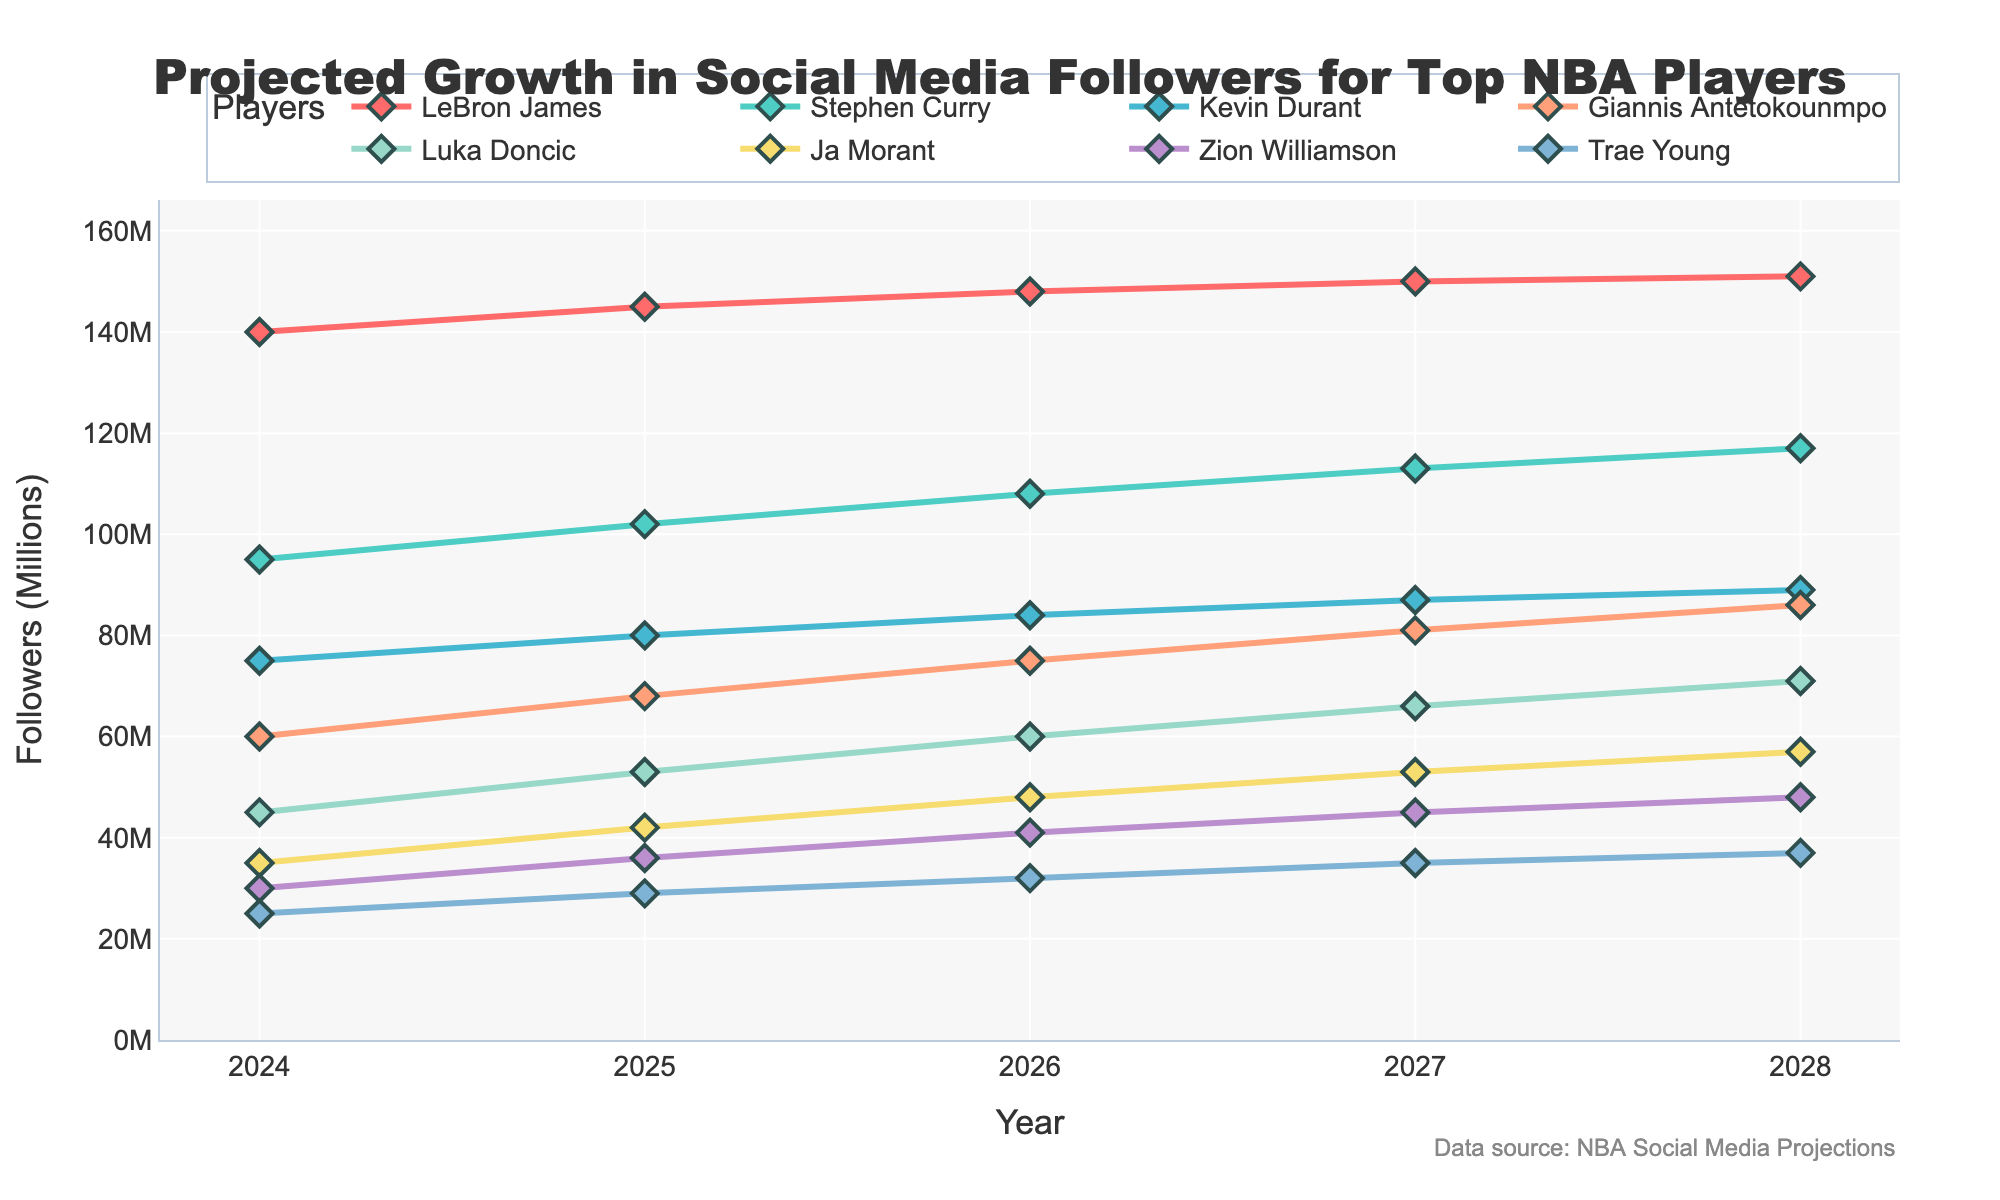What is the title of the plot? The title of the plot is located at the top center of the figure.
Answer: Projected Growth in Social Media Followers for Top NBA Players What is the projected number of followers for Stephen Curry in 2025? By looking at the series of data points for Stephen Curry, find the one corresponding to the year 2025.
Answer: 102M Who has the lowest projected number of followers in 2028? Compare the data points for each player in the year 2028 to find the lowest value.
Answer: Trae Young What is the total projected number of followers for Luka Doncic over the next 5 years? Add up Luka Doncic's projected followers for each year from 2024 to 2028. The values are 45, 53, 60, 66, and 71.
Answer: 295M Which player is projected to have the highest number of followers in 2026? Look at the data points for all players in the year 2026 and find the highest value.
Answer: LeBron James What is the average projected growth in followers per year for Giannis Antetokounmpo from 2024 to 2028? Find the difference in followers for Giannis in 2024 and 2028, then divide by the number of years (5) to get the average annual growth. (86-60)/5 = 5.2
Answer: 5.2M Between LeBron James and Kevin Durant, who has the larger projected follower increase from 2024 to 2028? Calculate the difference between the projected followers in 2028 and 2024 for both players, then compare the two differences. LeBron James: 151-140 = 11, Kevin Durant: 89-75 = 14
Answer: Kevin Durant Which two players have the closest projected followers in 2027? Identify the projected followers for all players in 2027, then compare the values to determine the two closest numbers.
Answer: Kevin Durant and Giannis Antetokounmpo By how much is Zion Williamson's projected followers in 2028 greater than Ja Morant's in 2025? Subtract the projected followers for Ja Morant in 2025 from Zion Williamson in 2028. Zion (2028): 48, Ja Morant (2025): 42, 48-42 = 6
Answer: 6M 